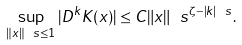Convert formula to latex. <formula><loc_0><loc_0><loc_500><loc_500>\sup _ { \| x \| _ { \ } s \leq 1 } | D ^ { k } K ( x ) | \leq C \| x \| _ { \ } s ^ { \zeta - | k | _ { \ } s } .</formula> 